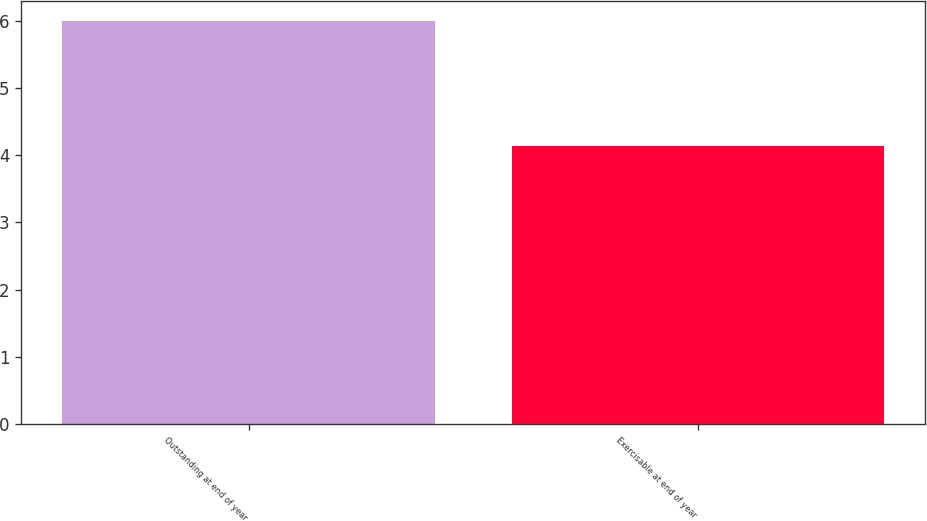Convert chart to OTSL. <chart><loc_0><loc_0><loc_500><loc_500><bar_chart><fcel>Outstanding at end of year<fcel>Exercisable at end of year<nl><fcel>6<fcel>4.14<nl></chart> 